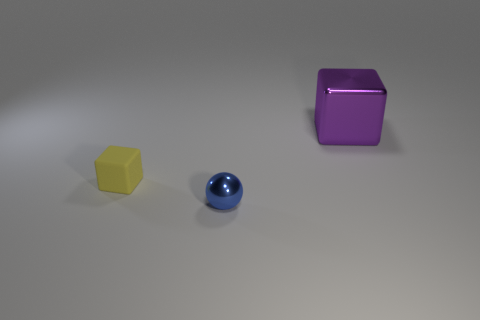Add 3 big shiny blocks. How many objects exist? 6 Subtract all blocks. How many objects are left? 1 Add 2 large purple blocks. How many large purple blocks are left? 3 Add 3 purple metal things. How many purple metal things exist? 4 Subtract 0 green balls. How many objects are left? 3 Subtract all big yellow shiny balls. Subtract all yellow things. How many objects are left? 2 